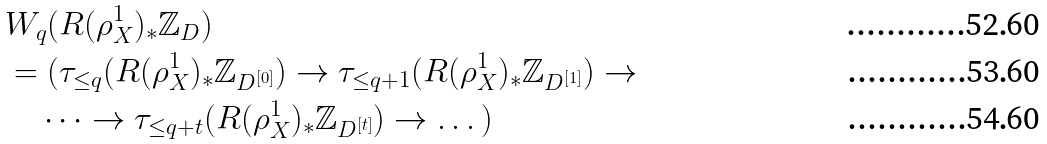Convert formula to latex. <formula><loc_0><loc_0><loc_500><loc_500>& W _ { q } ( R ( \rho _ { X } ^ { 1 } ) _ { * } \mathbb { Z } _ { D } ) \\ & = ( \tau _ { \leq q } ( R ( \rho _ { X } ^ { 1 } ) _ { * } \mathbb { Z } _ { D ^ { [ 0 ] } } ) \to \tau _ { \leq q + 1 } ( R ( \rho _ { X } ^ { 1 } ) _ { * } \mathbb { Z } _ { D ^ { [ 1 ] } } ) \to \\ & \quad \dots \to \tau _ { \leq q + t } ( R ( \rho _ { X } ^ { 1 } ) _ { * } \mathbb { Z } _ { D ^ { [ t ] } } ) \to \dots )</formula> 